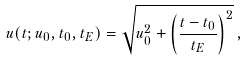<formula> <loc_0><loc_0><loc_500><loc_500>u ( t ; u _ { 0 } , t _ { 0 } , t _ { E } ) = \sqrt { u _ { 0 } ^ { 2 } + \left ( \frac { t - t _ { 0 } } { t _ { E } } \right ) ^ { 2 } } \, ,</formula> 